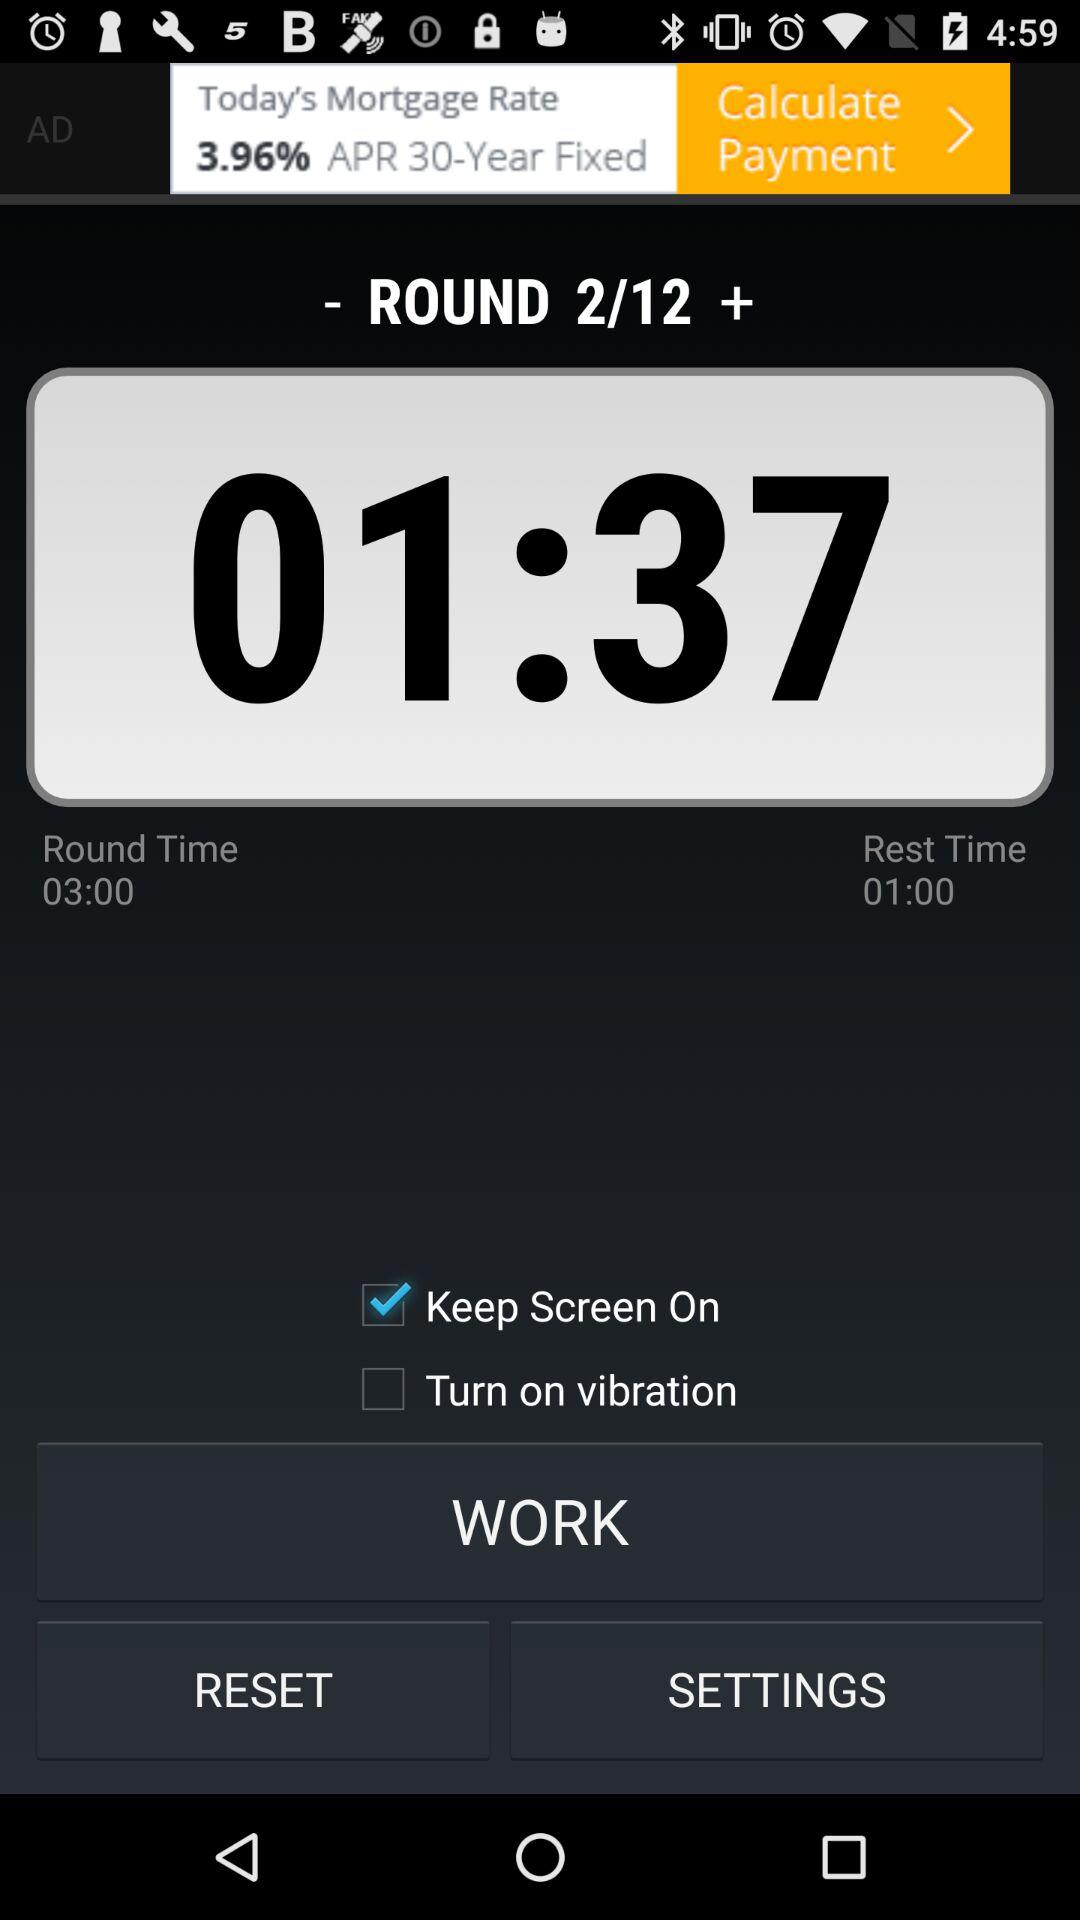What is the status of "Keep Screen On"? The status is "on". 